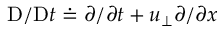Convert formula to latex. <formula><loc_0><loc_0><loc_500><loc_500>D / D t \doteq \partial / \partial t + u _ { \perp } \partial / \partial x</formula> 